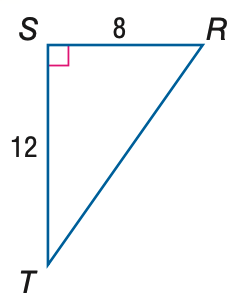Question: Find the measure of \angle T to the nearest tenth.
Choices:
A. 33.7
B. 41.8
C. 48.2
D. 56.3
Answer with the letter. Answer: A 